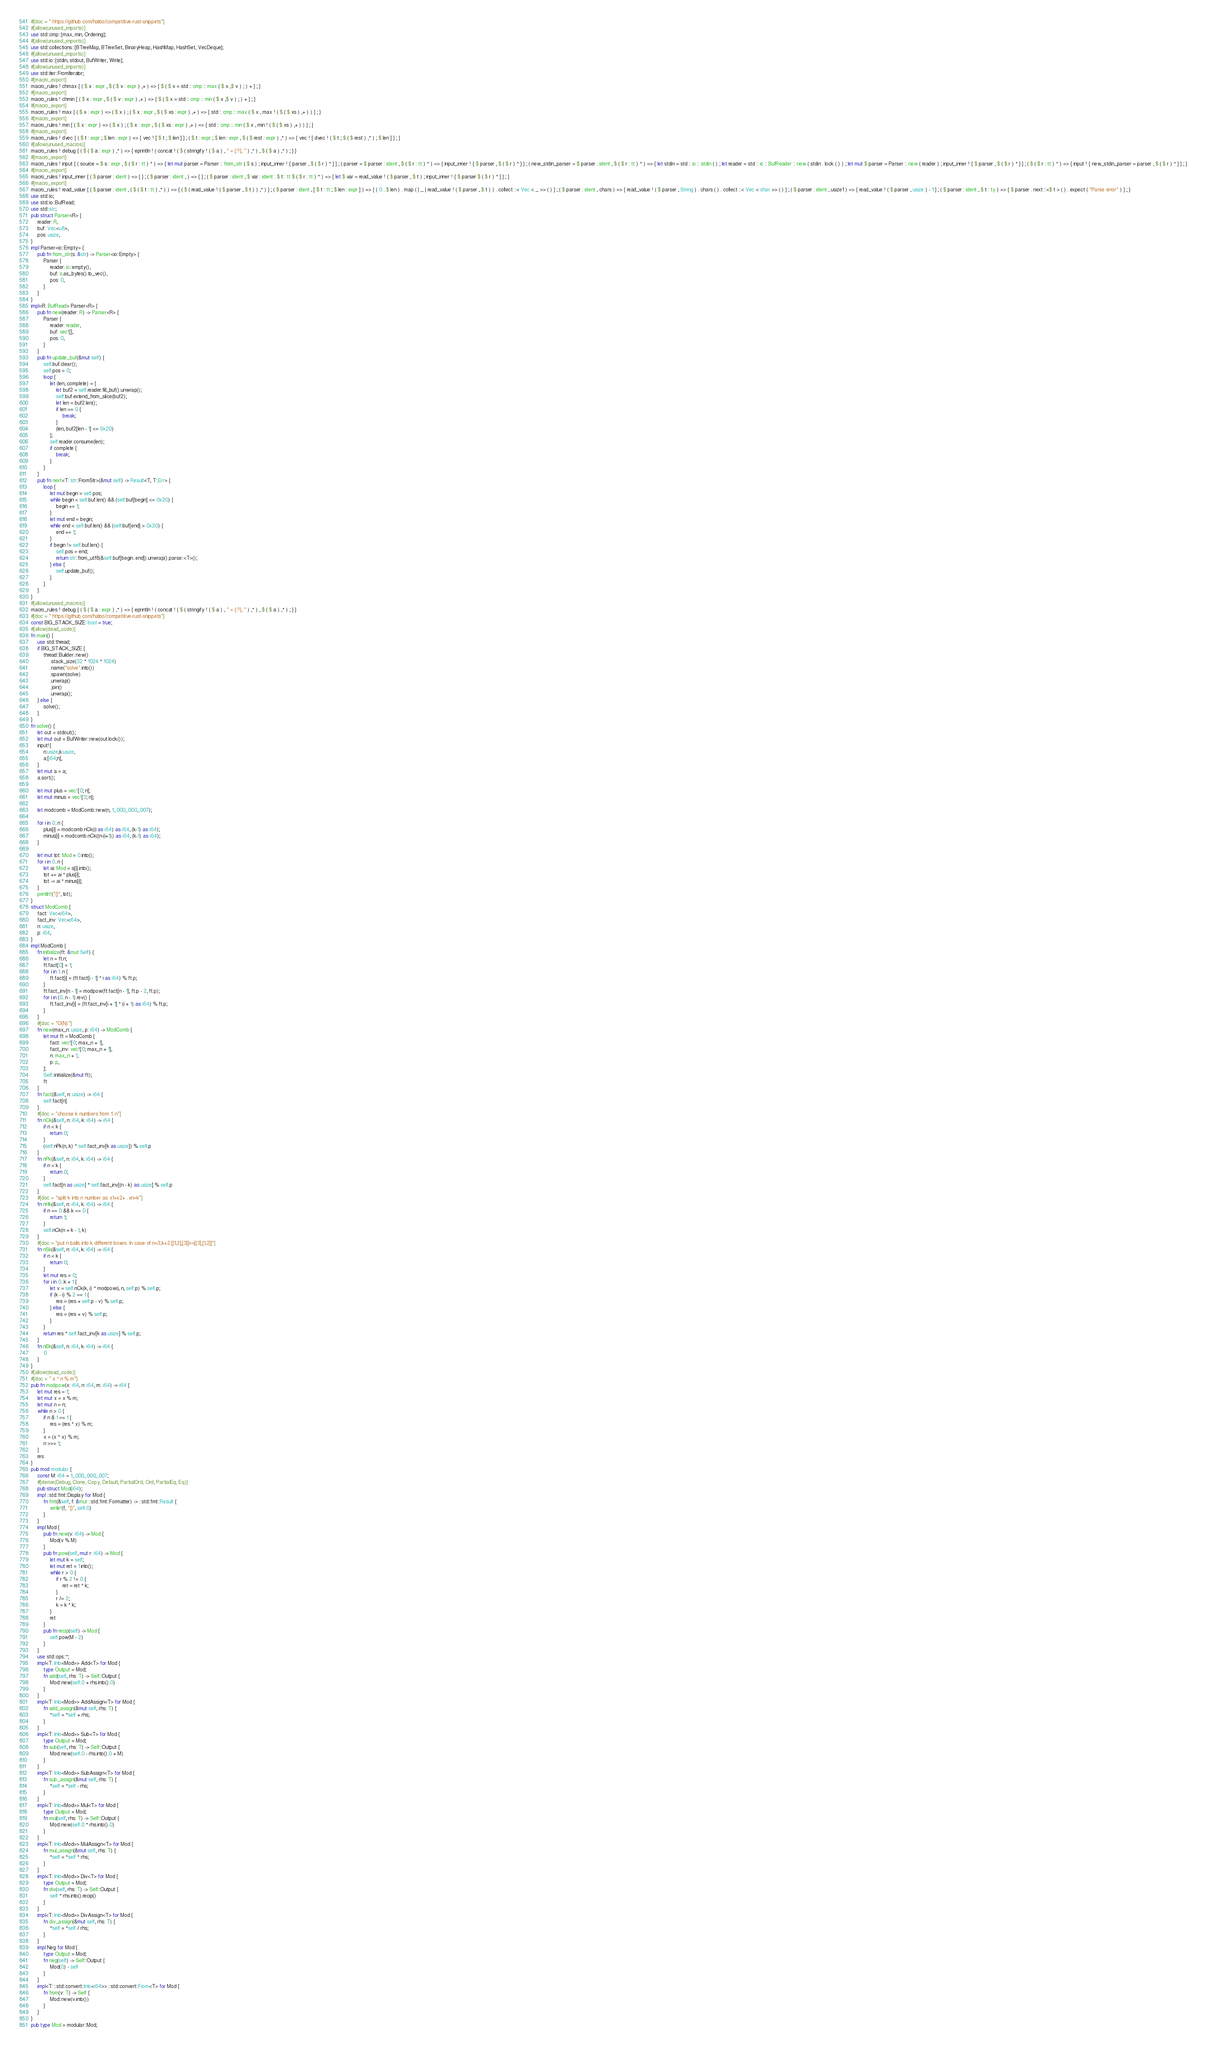<code> <loc_0><loc_0><loc_500><loc_500><_Rust_>#[doc = " https://github.com/hatoo/competitive-rust-snippets"]
#[allow(unused_imports)]
use std::cmp::{max, min, Ordering};
#[allow(unused_imports)]
use std::collections::{BTreeMap, BTreeSet, BinaryHeap, HashMap, HashSet, VecDeque};
#[allow(unused_imports)]
use std::io::{stdin, stdout, BufWriter, Write};
#[allow(unused_imports)]
use std::iter::FromIterator;
#[macro_export]
macro_rules ! chmax { ( $ x : expr , $ ( $ v : expr ) ,+ ) => { $ ( $ x = std :: cmp :: max ( $ x ,$ v ) ; ) + } ; }
#[macro_export]
macro_rules ! chmin { ( $ x : expr , $ ( $ v : expr ) ,+ ) => { $ ( $ x = std :: cmp :: min ( $ x ,$ v ) ; ) + } ; }
#[macro_export]
macro_rules ! max { ( $ x : expr ) => ( $ x ) ; ( $ x : expr , $ ( $ xs : expr ) ,+ ) => { std :: cmp :: max ( $ x , max ! ( $ ( $ xs ) ,+ ) ) } ; }
#[macro_export]
macro_rules ! min { ( $ x : expr ) => ( $ x ) ; ( $ x : expr , $ ( $ xs : expr ) ,+ ) => { std :: cmp :: min ( $ x , min ! ( $ ( $ xs ) ,+ ) ) } ; }
#[macro_export]
macro_rules ! dvec { ( $ t : expr ; $ len : expr ) => { vec ! [ $ t ; $ len ] } ; ( $ t : expr ; $ len : expr , $ ( $ rest : expr ) ,* ) => { vec ! [ dvec ! ( $ t ; $ ( $ rest ) ,* ) ; $ len ] } ; }
#[allow(unused_macros)]
macro_rules ! debug { ( $ ( $ a : expr ) ,* ) => { eprintln ! ( concat ! ( $ ( stringify ! ( $ a ) , " = {:?}, " ) ,* ) , $ ( $ a ) ,* ) ; } }
#[macro_export]
macro_rules ! input { ( source = $ s : expr , $ ( $ r : tt ) * ) => { let mut parser = Parser :: from_str ( $ s ) ; input_inner ! { parser , $ ( $ r ) * } } ; ( parser = $ parser : ident , $ ( $ r : tt ) * ) => { input_inner ! { $ parser , $ ( $ r ) * } } ; ( new_stdin_parser = $ parser : ident , $ ( $ r : tt ) * ) => { let stdin = std :: io :: stdin ( ) ; let reader = std :: io :: BufReader :: new ( stdin . lock ( ) ) ; let mut $ parser = Parser :: new ( reader ) ; input_inner ! { $ parser , $ ( $ r ) * } } ; ( $ ( $ r : tt ) * ) => { input ! { new_stdin_parser = parser , $ ( $ r ) * } } ; }
#[macro_export]
macro_rules ! input_inner { ( $ parser : ident ) => { } ; ( $ parser : ident , ) => { } ; ( $ parser : ident , $ var : ident : $ t : tt $ ( $ r : tt ) * ) => { let $ var = read_value ! ( $ parser , $ t ) ; input_inner ! { $ parser $ ( $ r ) * } } ; }
#[macro_export]
macro_rules ! read_value { ( $ parser : ident , ( $ ( $ t : tt ) ,* ) ) => { ( $ ( read_value ! ( $ parser , $ t ) ) ,* ) } ; ( $ parser : ident , [ $ t : tt ; $ len : expr ] ) => { ( 0 ..$ len ) . map ( | _ | read_value ! ( $ parser , $ t ) ) . collect ::< Vec < _ >> ( ) } ; ( $ parser : ident , chars ) => { read_value ! ( $ parser , String ) . chars ( ) . collect ::< Vec < char >> ( ) } ; ( $ parser : ident , usize1 ) => { read_value ! ( $ parser , usize ) - 1 } ; ( $ parser : ident , $ t : ty ) => { $ parser . next ::<$ t > ( ) . expect ( "Parse error" ) } ; }
use std::io;
use std::io::BufRead;
use std::str;
pub struct Parser<R> {
    reader: R,
    buf: Vec<u8>,
    pos: usize,
}
impl Parser<io::Empty> {
    pub fn from_str(s: &str) -> Parser<io::Empty> {
        Parser {
            reader: io::empty(),
            buf: s.as_bytes().to_vec(),
            pos: 0,
        }
    }
}
impl<R: BufRead> Parser<R> {
    pub fn new(reader: R) -> Parser<R> {
        Parser {
            reader: reader,
            buf: vec![],
            pos: 0,
        }
    }
    pub fn update_buf(&mut self) {
        self.buf.clear();
        self.pos = 0;
        loop {
            let (len, complete) = {
                let buf2 = self.reader.fill_buf().unwrap();
                self.buf.extend_from_slice(buf2);
                let len = buf2.len();
                if len == 0 {
                    break;
                }
                (len, buf2[len - 1] <= 0x20)
            };
            self.reader.consume(len);
            if complete {
                break;
            }
        }
    }
    pub fn next<T: str::FromStr>(&mut self) -> Result<T, T::Err> {
        loop {
            let mut begin = self.pos;
            while begin < self.buf.len() && (self.buf[begin] <= 0x20) {
                begin += 1;
            }
            let mut end = begin;
            while end < self.buf.len() && (self.buf[end] > 0x20) {
                end += 1;
            }
            if begin != self.buf.len() {
                self.pos = end;
                return str::from_utf8(&self.buf[begin..end]).unwrap().parse::<T>();
            } else {
                self.update_buf();
            }
        }
    }
}
#[allow(unused_macros)]
macro_rules ! debug { ( $ ( $ a : expr ) ,* ) => { eprintln ! ( concat ! ( $ ( stringify ! ( $ a ) , " = {:?}, " ) ,* ) , $ ( $ a ) ,* ) ; } }
#[doc = " https://github.com/hatoo/competitive-rust-snippets"]
const BIG_STACK_SIZE: bool = true;
#[allow(dead_code)]
fn main() {
    use std::thread;
    if BIG_STACK_SIZE {
        thread::Builder::new()
            .stack_size(32 * 1024 * 1024)
            .name("solve".into())
            .spawn(solve)
            .unwrap()
            .join()
            .unwrap();
    } else {
        solve();
    }
}
fn solve() {
    let out = stdout();
    let mut out = BufWriter::new(out.lock());
    input!{
        n:usize,k:usize,
        a:[i64;n],
    }
    let mut a = a;
    a.sort();

    let mut plus = vec![0; n];
    let mut minus = vec![0; n];

    let modcomb = ModComb::new(n, 1_000_000_007);

    for i in 0..n {
        plus[i] = modcomb.nCk((i as i64) as i64, (k-1) as i64);
        minus[i] = modcomb.nCk((n-(i+1)) as i64, (k-1) as i64);
    }

    let mut tot: Mod = 0.into();
    for i in 0..n {
        let ai: Mod = a[i].into();
        tot += ai * plus[i];
        tot -= ai * minus[i];
    }
    println!("{}", tot);
}
struct ModComb {
    fact: Vec<i64>,
    fact_inv: Vec<i64>,
    n: usize,
    p: i64,
}
impl ModComb {
    fn initialize(ft: &mut Self) {
        let n = ft.n;
        ft.fact[0] = 1;
        for i in 1..n {
            ft.fact[i] = (ft.fact[i - 1] * i as i64) % ft.p;
        }
        ft.fact_inv[n - 1] = modpow(ft.fact[n - 1], ft.p - 2, ft.p);
        for i in (0..n - 1).rev() {
            ft.fact_inv[i] = (ft.fact_inv[i + 1] * (i + 1) as i64) % ft.p;
        }
    }
    #[doc = "O(N)"]
    fn new(max_n: usize, p: i64) -> ModComb {
        let mut ft = ModComb {
            fact: vec![0; max_n + 1],
            fact_inv: vec![0; max_n + 1],
            n: max_n + 1,
            p: p,
        };
        Self::initialize(&mut ft);
        ft
    }
    fn fact(&self, n: usize) -> i64 {
        self.fact[n]
    }
    #[doc = "choose k numbers from 1..n"]
    fn nCk(&self, n: i64, k: i64) -> i64 {
        if n < k {
            return 0;
        }
        (self.nPk(n, k) * self.fact_inv[k as usize]) % self.p
    }
    fn nPk(&self, n: i64, k: i64) -> i64 {
        if n < k {
            return 0;
        }
        self.fact[n as usize] * self.fact_inv[(n - k) as usize] % self.p
    }
    #[doc = "split k into n number as x1+x2+...xn=k"]
    fn nHk(&self, n: i64, k: i64) -> i64 {
        if n == 0 && k == 0 {
            return 1;
        }
        self.nCk(n + k - 1, k)
    }
    #[doc = "put n balls into k different boxes. In case of n=3,k+2 [[1,2],[3]]==[[3],[1,2]]"]
    fn nSk(&self, n: i64, k: i64) -> i64 {
        if n < k {
            return 0;
        }
        let mut res = 0;
        for i in 0..k + 1 {
            let v = self.nCk(k, i) * modpow(i, n, self.p) % self.p;
            if (k - i) % 2 == 1 {
                res = (res + self.p - v) % self.p;
            } else {
                res = (res + v) % self.p;
            }
        }
        return res * self.fact_inv[k as usize] % self.p;
    }
    fn nBk(&self, n: i64, k: i64) -> i64 {
        0
    }
}
#[allow(dead_code)]
#[doc = " x ^ n % m"]
pub fn modpow(x: i64, n: i64, m: i64) -> i64 {
    let mut res = 1;
    let mut x = x % m;
    let mut n = n;
    while n > 0 {
        if n & 1 == 1 {
            res = (res * x) % m;
        }
        x = (x * x) % m;
        n >>= 1;
    }
    res
}
pub mod modular {
    const M: i64 = 1_000_000_007;
    #[derive(Debug, Clone, Copy, Default, PartialOrd, Ord, PartialEq, Eq)]
    pub struct Mod(i64);
    impl ::std::fmt::Display for Mod {
        fn fmt(&self, f: &mut ::std::fmt::Formatter) -> ::std::fmt::Result {
            write!(f, "{}", self.0)
        }
    }
    impl Mod {
        pub fn new(v: i64) -> Mod {
            Mod(v % M)
        }
        pub fn pow(self, mut r: i64) -> Mod {
            let mut k = self;
            let mut ret = 1.into();
            while r > 0 {
                if r % 2 != 0 {
                    ret = ret * k;
                }
                r /= 2;
                k = k * k;
            }
            ret
        }
        pub fn recip(self) -> Mod {
            self.pow(M - 2)
        }
    }
    use std::ops::*;
    impl<T: Into<Mod>> Add<T> for Mod {
        type Output = Mod;
        fn add(self, rhs: T) -> Self::Output {
            Mod::new(self.0 + rhs.into().0)
        }
    }
    impl<T: Into<Mod>> AddAssign<T> for Mod {
        fn add_assign(&mut self, rhs: T) {
            *self = *self + rhs;
        }
    }
    impl<T: Into<Mod>> Sub<T> for Mod {
        type Output = Mod;
        fn sub(self, rhs: T) -> Self::Output {
            Mod::new(self.0 - rhs.into().0 + M)
        }
    }
    impl<T: Into<Mod>> SubAssign<T> for Mod {
        fn sub_assign(&mut self, rhs: T) {
            *self = *self - rhs;
        }
    }
    impl<T: Into<Mod>> Mul<T> for Mod {
        type Output = Mod;
        fn mul(self, rhs: T) -> Self::Output {
            Mod::new(self.0 * rhs.into().0)
        }
    }
    impl<T: Into<Mod>> MulAssign<T> for Mod {
        fn mul_assign(&mut self, rhs: T) {
            *self = *self * rhs;
        }
    }
    impl<T: Into<Mod>> Div<T> for Mod {
        type Output = Mod;
        fn div(self, rhs: T) -> Self::Output {
            self * rhs.into().recip()
        }
    }
    impl<T: Into<Mod>> DivAssign<T> for Mod {
        fn div_assign(&mut self, rhs: T) {
            *self = *self / rhs;
        }
    }
    impl Neg for Mod {
        type Output = Mod;
        fn neg(self) -> Self::Output {
            Mod(0) - self
        }
    }
    impl<T: ::std::convert::Into<i64>> ::std::convert::From<T> for Mod {
        fn from(v: T) -> Self {
            Mod::new(v.into())
        }
    }
}
pub type Mod = modular::Mod;</code> 